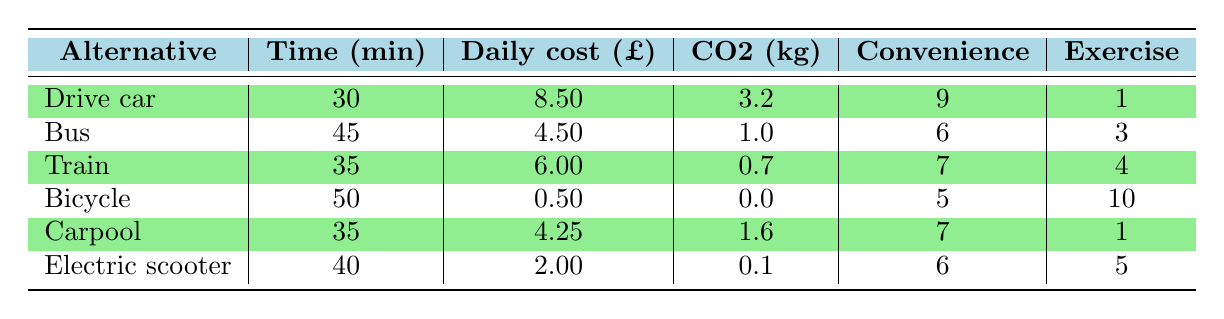What is the time taken by the bus for a commute? Referring to the table, the time taken by the bus is directly listed under the "Time (minutes)" column. The value associated with the bus alternative is 45 minutes.
Answer: 45 minutes Which alternative has the lowest daily cost? The "Daily cost (£)" column lists the costs for each alternative. The bicycle has the lowest cost at £0.50.
Answer: £0.50 Is the CO2 emissions for carpool less than the emissions for bus? Comparing the "CO2 emissions (kg)" values, the bus has 1.0 kg while the carpool has 1.6 kg. Since 1.6 is greater than 1.0, the carpool emissions are not less.
Answer: No What is the average convenience rating for all alternatives? To find the average convenience rating, sum the convenience ratings (9 + 6 + 7 + 5 + 7 + 6 = 40) and divide by the number of alternatives (6). This results in an average of 40/6 ≈ 6.67.
Answer: Approximately 6.67 Which alternative offers the highest exercise benefit? The "Exercise benefit (1-10)" column shows that the bicycle has the highest exercise benefit at 10.
Answer: Bicycle How much more does it cost to drive a car compared to taking an electric scooter? The daily cost of driving a car is £8.50 and the electric scooter is £2.00. The difference is 8.50 - 2.00 = £6.50.
Answer: £6.50 Does the train have higher convenience than the bicycle? Comparing the "Convenience" values, the train has a rating of 7 while the bicycle has a rating of 5. Since 7 is greater than 5, the train does have higher convenience.
Answer: Yes What is the total CO2 emissions of commuting by bus and train together? The CO2 emissions for the bus are 1.0 kg and for the train, it is 0.7 kg. Adding these values together gives a total of 1.0 + 0.7 = 1.7 kg.
Answer: 1.7 kg 